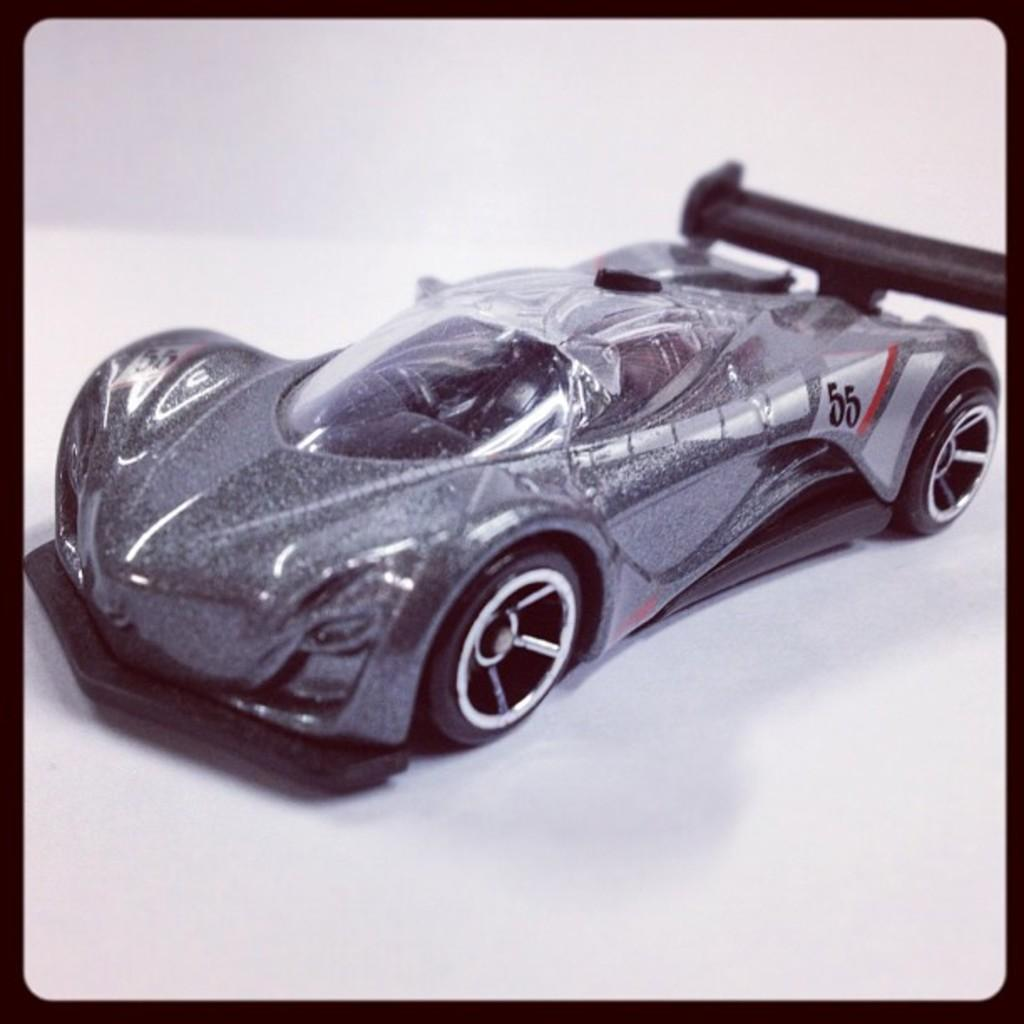<image>
Relay a brief, clear account of the picture shown. a car with the numbers 55 on the side 